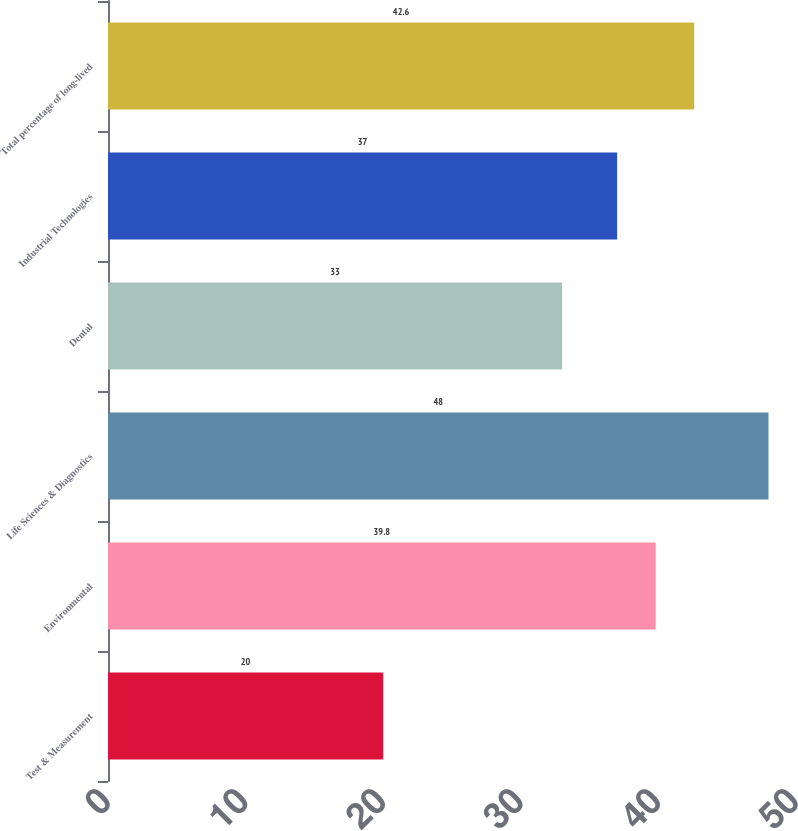Convert chart. <chart><loc_0><loc_0><loc_500><loc_500><bar_chart><fcel>Test & Measurement<fcel>Environmental<fcel>Life Sciences & Diagnostics<fcel>Dental<fcel>Industrial Technologies<fcel>Total percentage of long-lived<nl><fcel>20<fcel>39.8<fcel>48<fcel>33<fcel>37<fcel>42.6<nl></chart> 